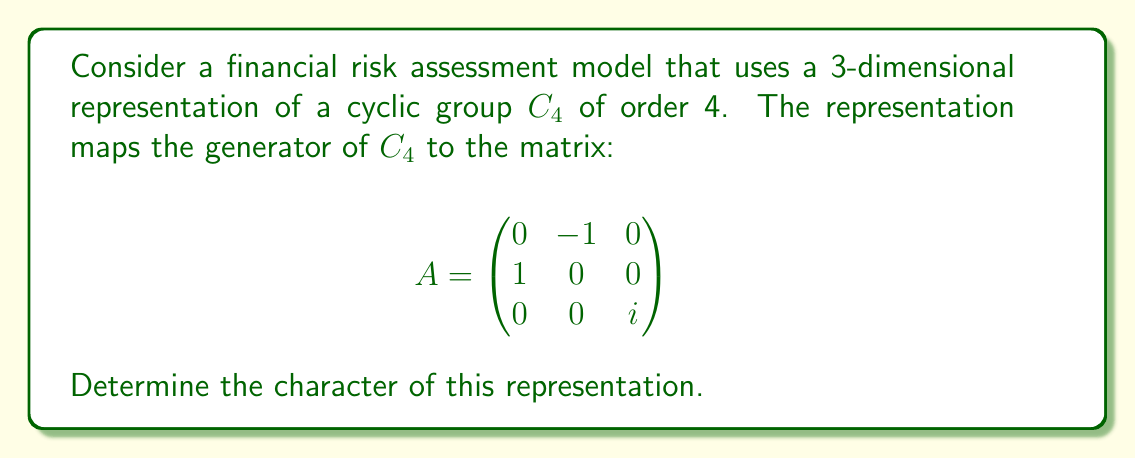Give your solution to this math problem. To determine the character of this representation, we need to follow these steps:

1) Recall that the character of a representation is a function that assigns to each group element the trace of its corresponding matrix in the representation.

2) For a cyclic group $C_4 = \{e, g, g^2, g^3\}$, we need to find the matrices corresponding to each element and calculate their traces.

3) We are given that $g$ is mapped to matrix $A$. Let's calculate the powers of $A$:

   $A^1 = A$ (given)
   
   $A^2 = \begin{pmatrix}
   -1 & 0 & 0 \\
   0 & -1 & 0 \\
   0 & 0 & -1
   \end{pmatrix}$
   
   $A^3 = \begin{pmatrix}
   0 & 1 & 0 \\
   -1 & 0 & 0 \\
   0 & 0 & -i
   \end{pmatrix}$
   
   $A^4 = I_3$ (identity matrix)

4) Now, let's calculate the trace of each matrix:

   $\text{Tr}(A^0) = \text{Tr}(I_3) = 1 + 1 + 1 = 3$
   $\text{Tr}(A^1) = 0 + 0 + i = i$
   $\text{Tr}(A^2) = -1 + (-1) + (-1) = -3$
   $\text{Tr}(A^3) = 0 + 0 + (-i) = -i$

5) The character $\chi$ of the representation is therefore:

   $\chi(e) = 3$
   $\chi(g) = i$
   $\chi(g^2) = -3$
   $\chi(g^3) = -i$

This completely determines the character of the representation.
Answer: $\chi = (3, i, -3, -i)$ 